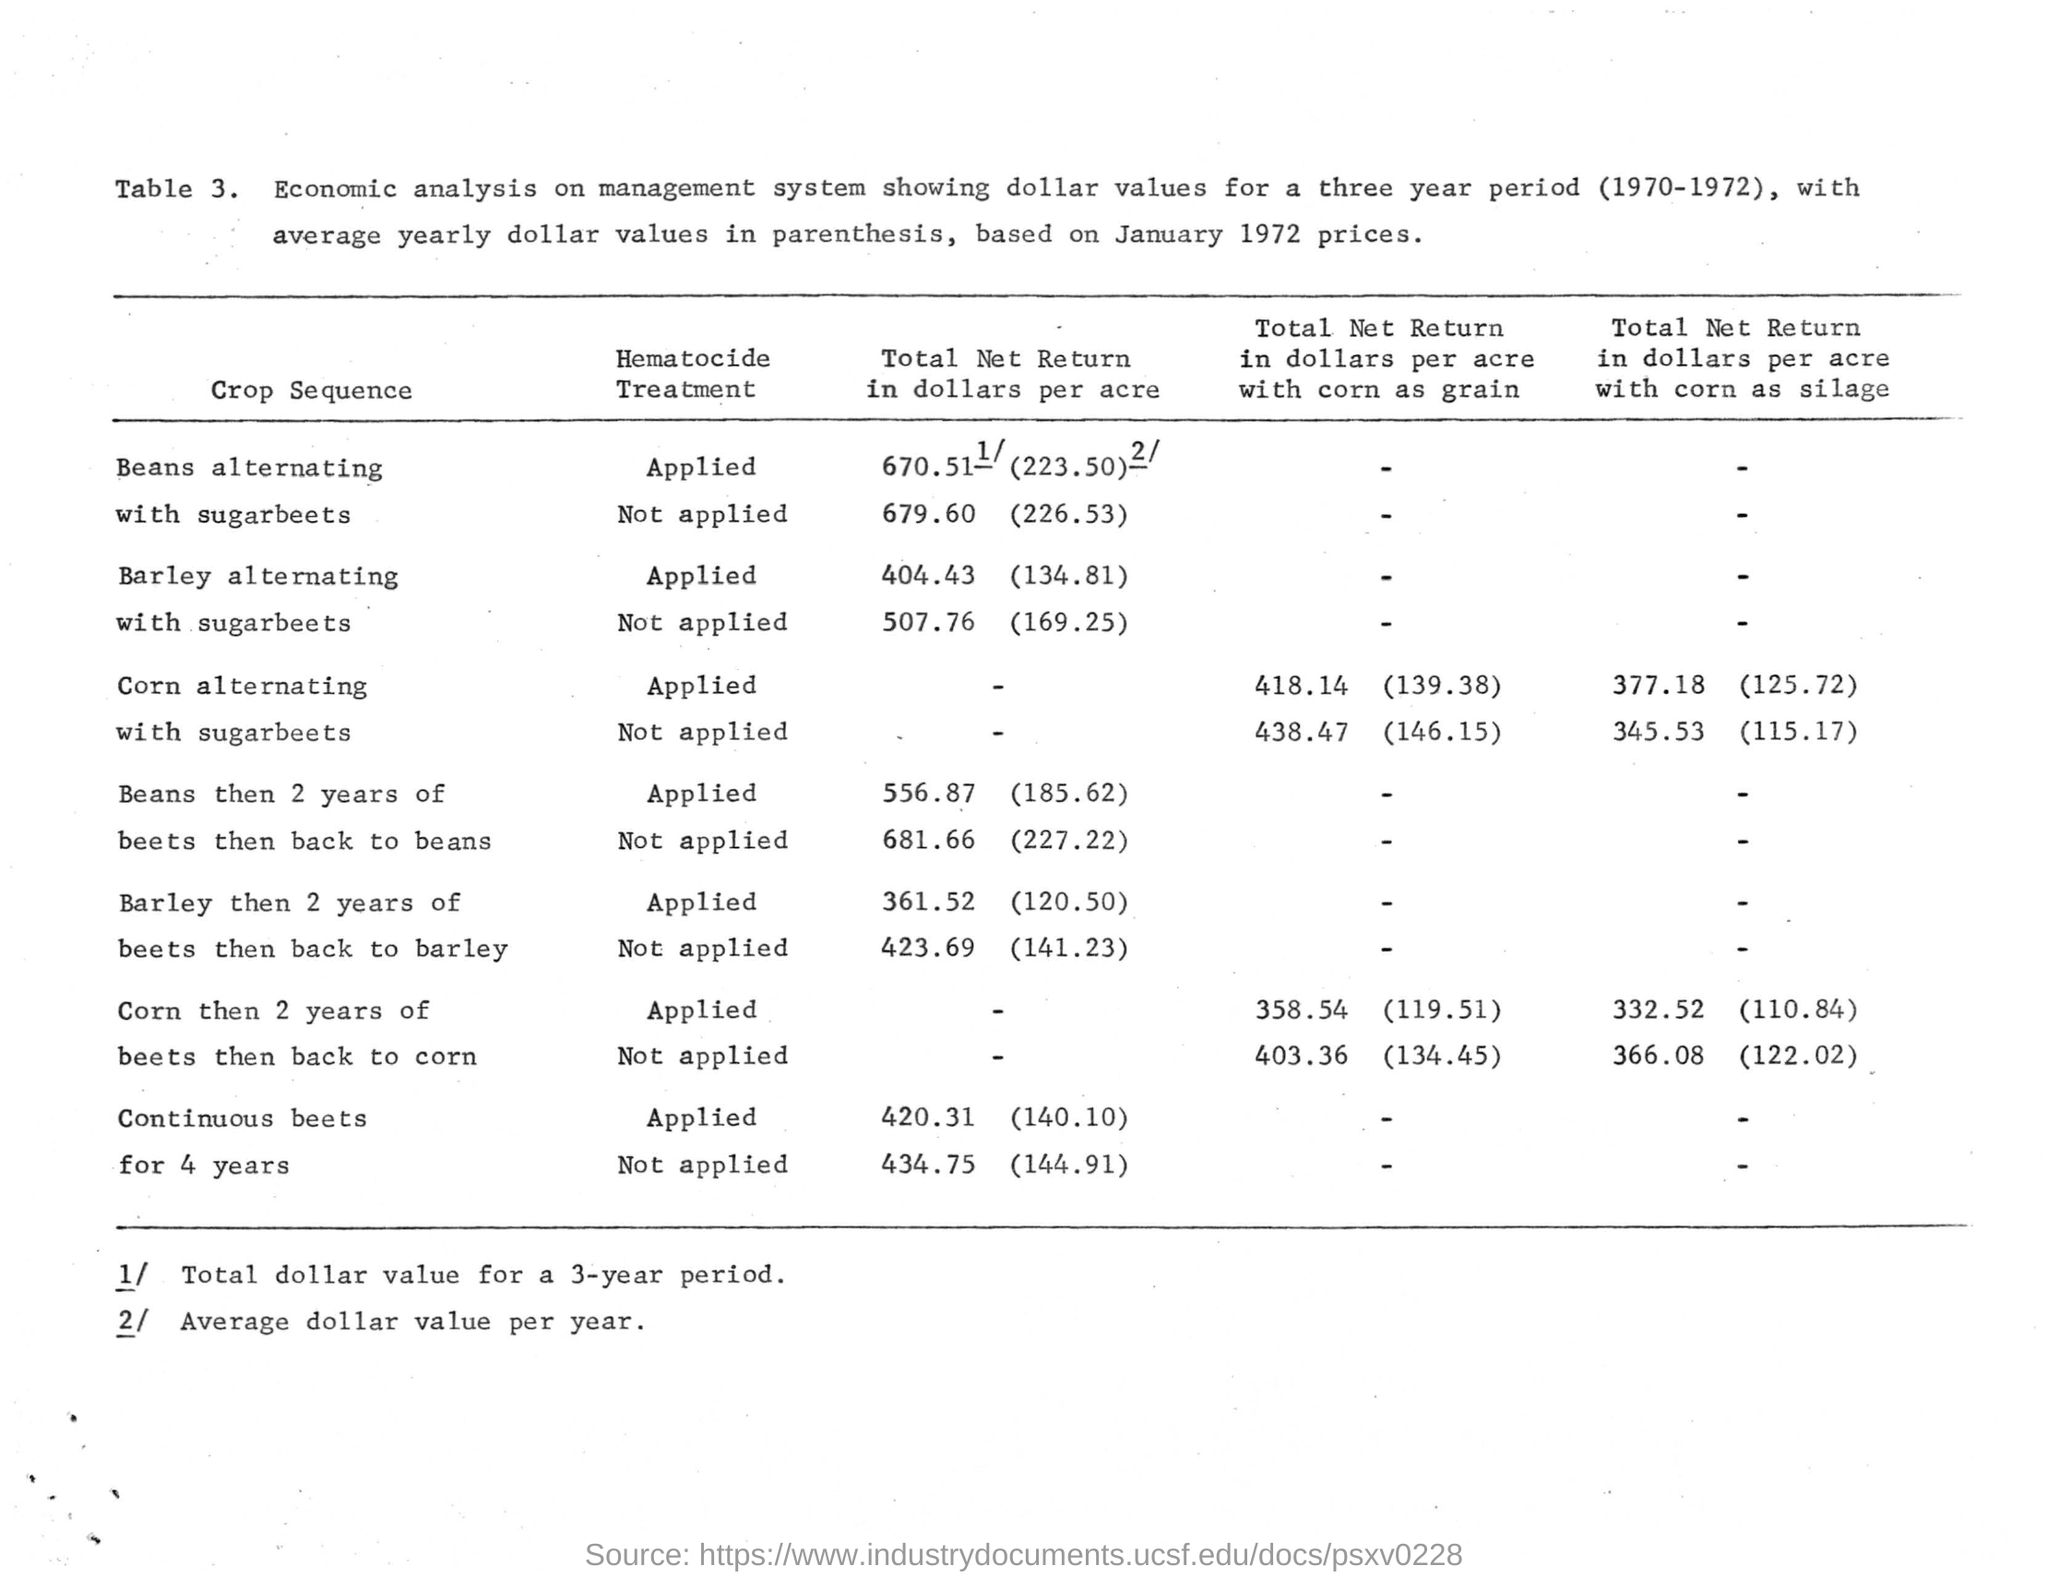What is the "Table" number?
Keep it short and to the point. 3. "Economic analysis on management system showing dollar values" for which three year period is shown in the "Table"?
Your answer should be very brief. 1970-1972. Based on which year's price, the average yearly dollar values in parenthesis is shown in the "Table 3"?
Provide a short and direct response. Based on january 1972 prices. What is the heading  given to the first column  of the "Table"?
Your answer should be compact. Crop Sequence. What is the heading given to the second column of the "Table"?
Offer a terse response. Hematocide Treatment. What is the heading given to the third column of the "Table 3"?
Offer a terse response. Total Net Return in dollars per acre. What is the last "CROP SEQUENCE" mentioned in the Table?
Your answer should be compact. Continuous beets for 4 years. What is the first "CROP SEQUENCE" mentioned in the Table?
Provide a short and direct response. Beans alternating with sugar beets. 